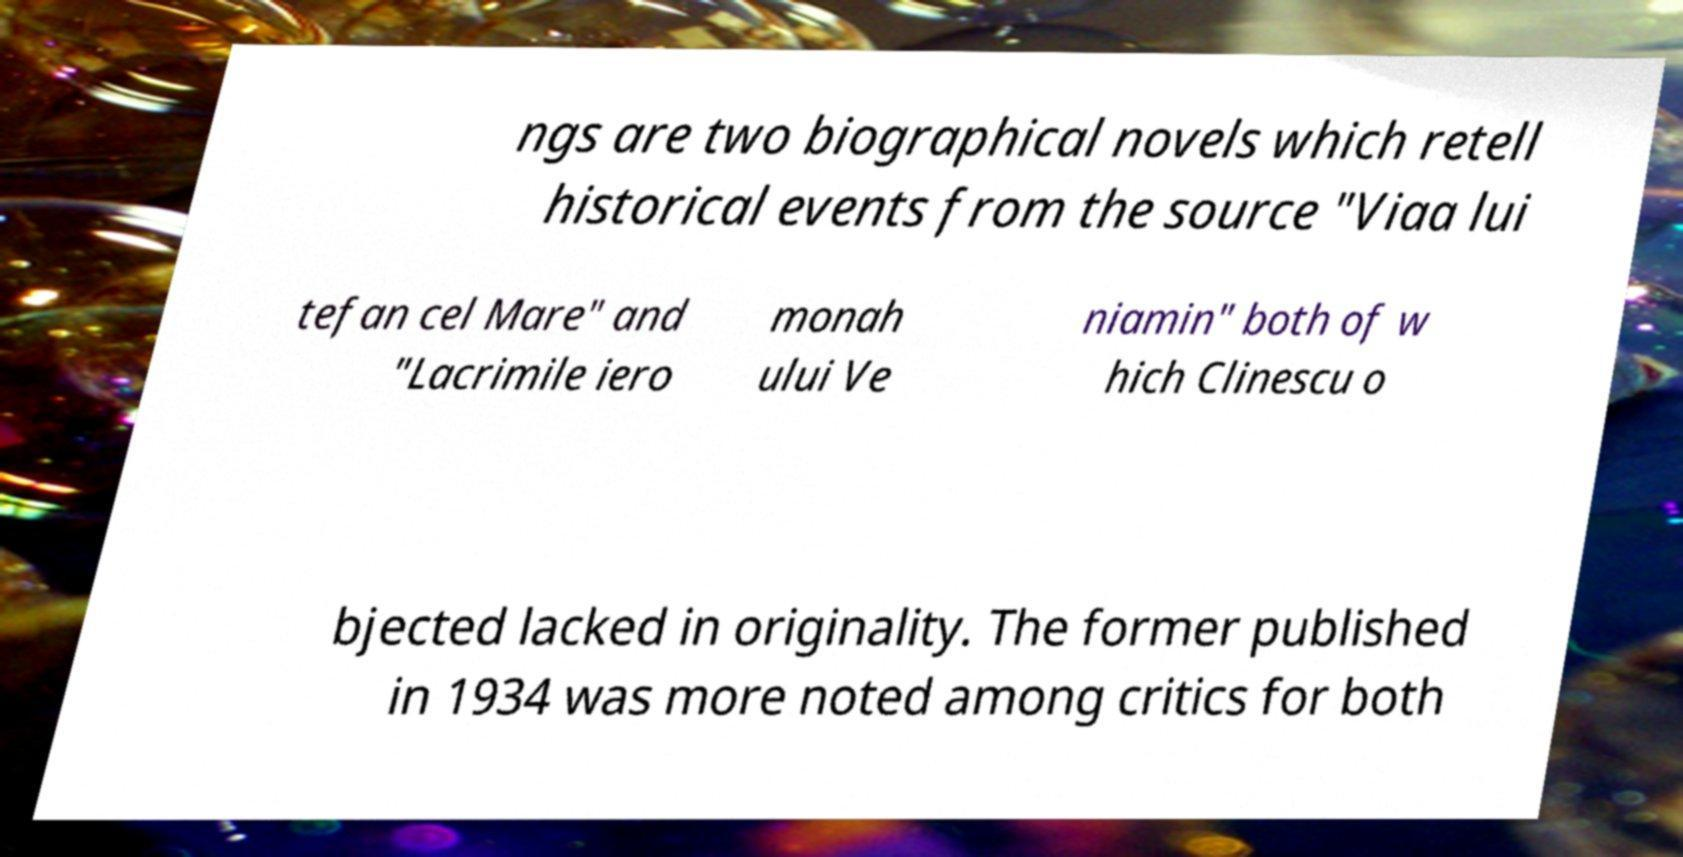Could you assist in decoding the text presented in this image and type it out clearly? ngs are two biographical novels which retell historical events from the source "Viaa lui tefan cel Mare" and "Lacrimile iero monah ului Ve niamin" both of w hich Clinescu o bjected lacked in originality. The former published in 1934 was more noted among critics for both 